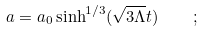Convert formula to latex. <formula><loc_0><loc_0><loc_500><loc_500>a = a _ { 0 } \sinh ^ { 1 / 3 } ( \sqrt { 3 \Lambda } t ) \quad ;</formula> 